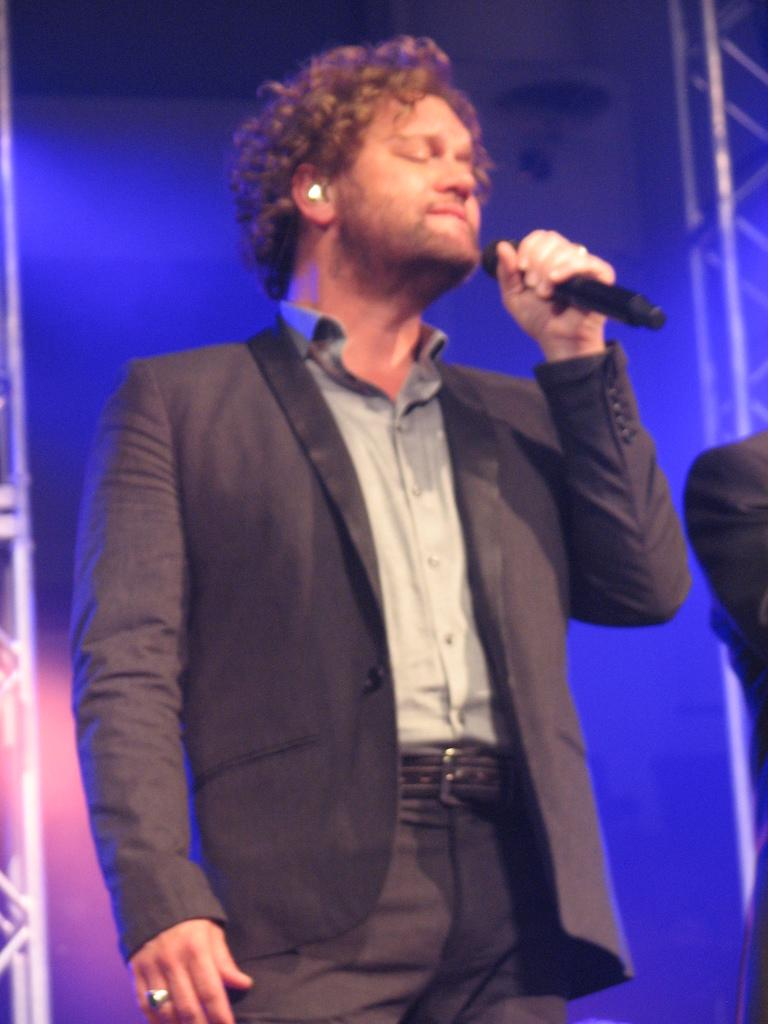What is the main subject of the image? There is a person in the image. What is the person wearing? The person is wearing a suit. What is the person doing in the image? The person is standing and singing. What object is in front of the person? There is a microphone in front of the person. What type of lipstick is the person wearing in the image? There is no indication of the person wearing lipstick in the image. Can you see any railings in the image? There is no mention of railings in the image. 